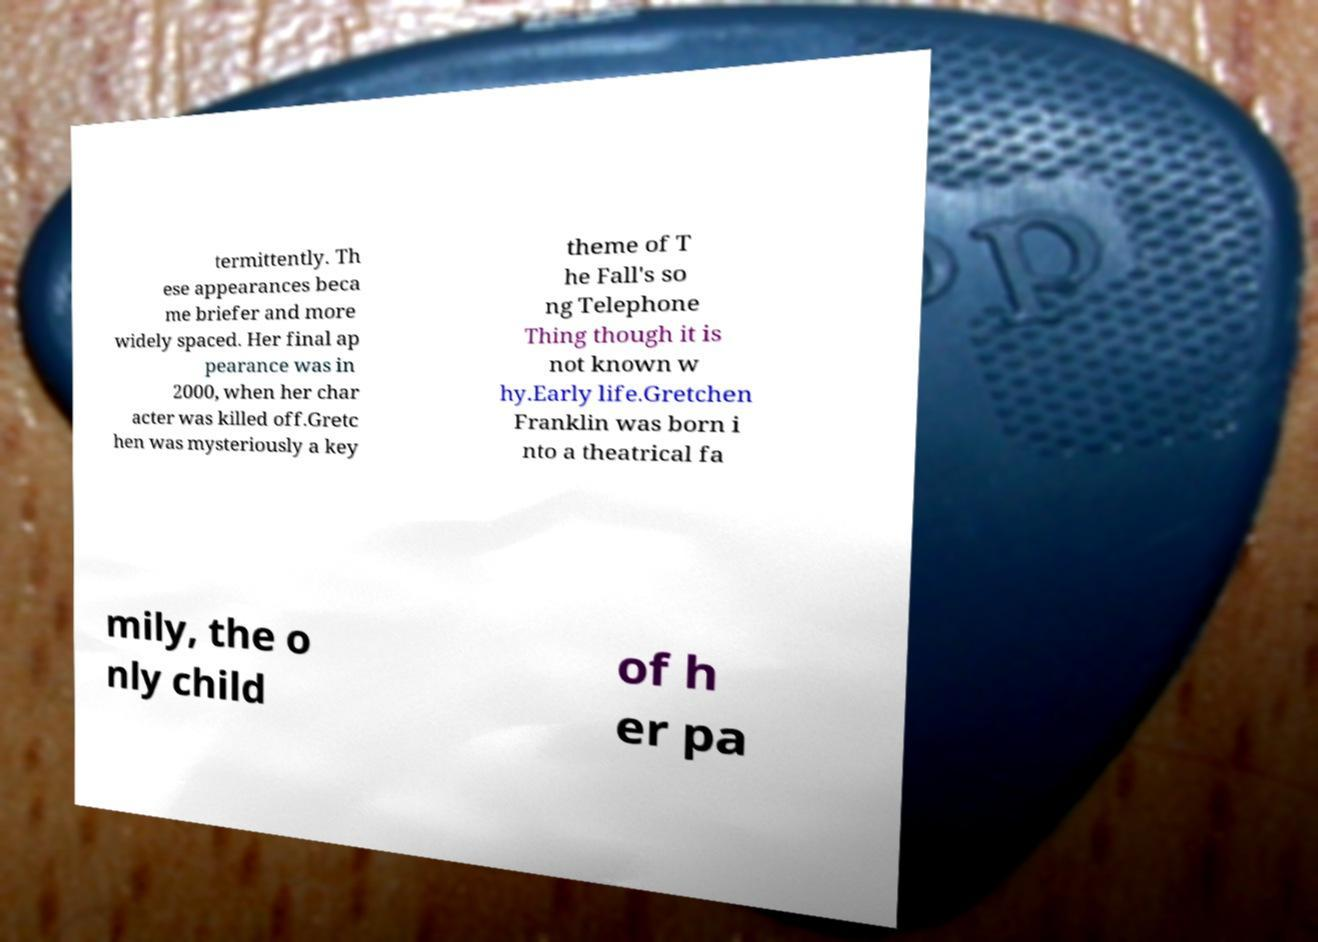For documentation purposes, I need the text within this image transcribed. Could you provide that? termittently. Th ese appearances beca me briefer and more widely spaced. Her final ap pearance was in 2000, when her char acter was killed off.Gretc hen was mysteriously a key theme of T he Fall's so ng Telephone Thing though it is not known w hy.Early life.Gretchen Franklin was born i nto a theatrical fa mily, the o nly child of h er pa 